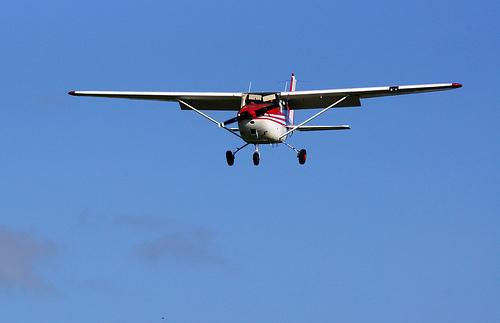Point out any distinctive markings on the airplane and their colors. The airplane has red and white stripes around the midsection, red tips on the wings, and a red nose. What color are the clouds and how do they look? The clouds are white in color and they appear wispy and dark in some areas. Which parts of the image mention the sky and describe its appearance? There are several parts mentioning the sky, describing it as clear blue, full of clouds, and having both grey wispy clouds and white clouds. Mention the number of wheels on the landing gear and their color. There are 3 black wheels on the landing gear. What color is the airplane and what is it doing? The airplane is red, white, and blue, and it is flying in the sky. Can you describe the airplane's wing and its color? The airplane's wing is long, white, and has red tips at its ends. Briefly describe the scene in the image including the airplane, sky, and clouds. The image shows a red, white, and blue airplane flying in a clear blue sky with some dark and grey wispy clouds. Is there anything else noteworthy about the airplane not yet mentioned? Yes, the airplane has a silver tail with a red stripe and silver wings with red distal ends. Mention the propeller's color and any additional detail on it. The propeller is black and has white stripes at the edge. What specific parts of the airplane can you see in the image? You can see the propeller, wings, windows, landing gear, red nose, and red tips on wings. 